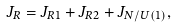Convert formula to latex. <formula><loc_0><loc_0><loc_500><loc_500>J _ { R } = J _ { R 1 } + J _ { R 2 } + J _ { N / U ( 1 ) } ,</formula> 